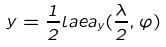Convert formula to latex. <formula><loc_0><loc_0><loc_500><loc_500>y = \frac { 1 } { 2 } l a e a _ { y } ( \frac { \lambda } { 2 } , \varphi )</formula> 